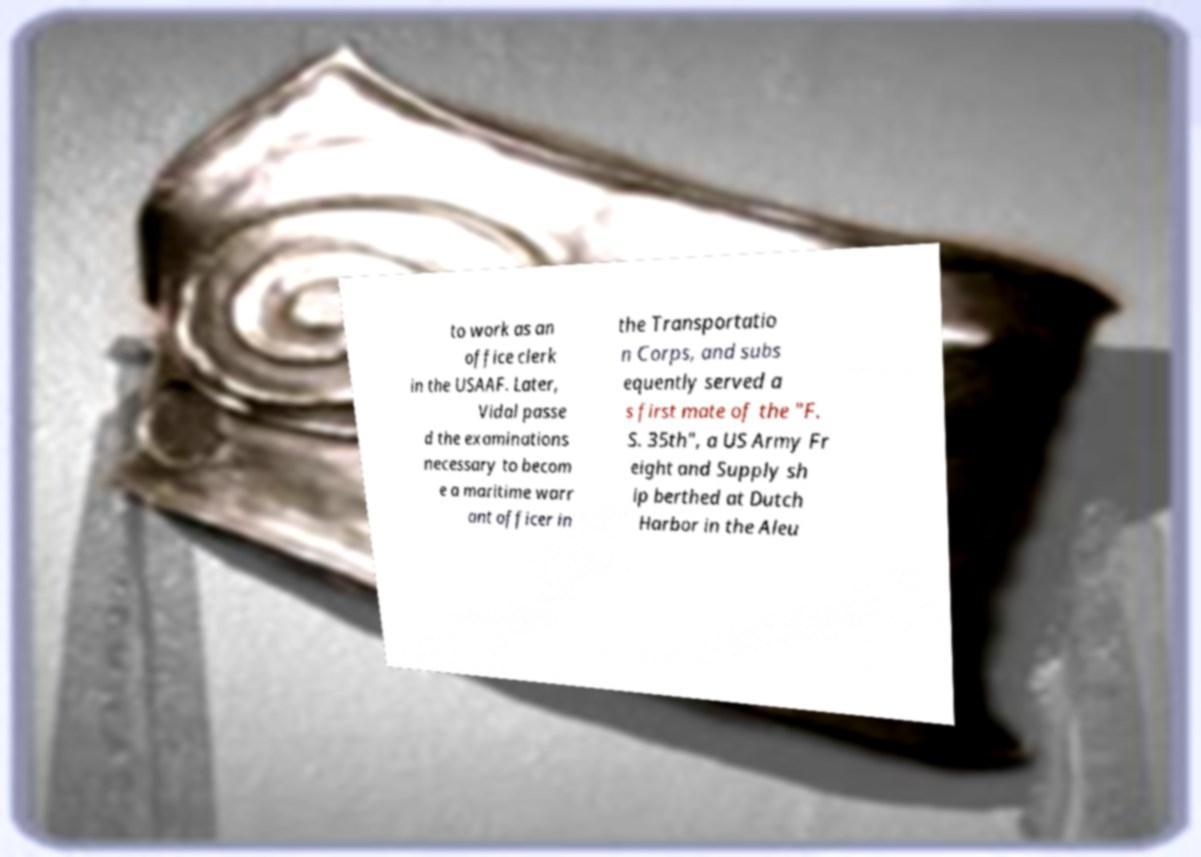There's text embedded in this image that I need extracted. Can you transcribe it verbatim? to work as an office clerk in the USAAF. Later, Vidal passe d the examinations necessary to becom e a maritime warr ant officer in the Transportatio n Corps, and subs equently served a s first mate of the "F. S. 35th", a US Army Fr eight and Supply sh ip berthed at Dutch Harbor in the Aleu 